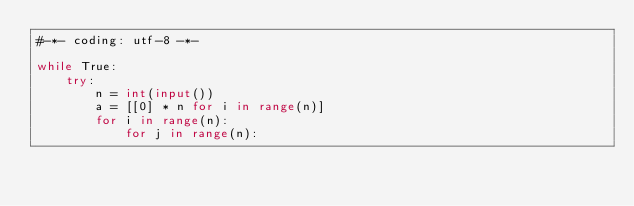Convert code to text. <code><loc_0><loc_0><loc_500><loc_500><_Python_>#-*- coding: utf-8 -*-

while True:
    try:
        n = int(input())
        a = [[0] * n for i in range(n)]
        for i in range(n):
            for j in range(n):</code> 